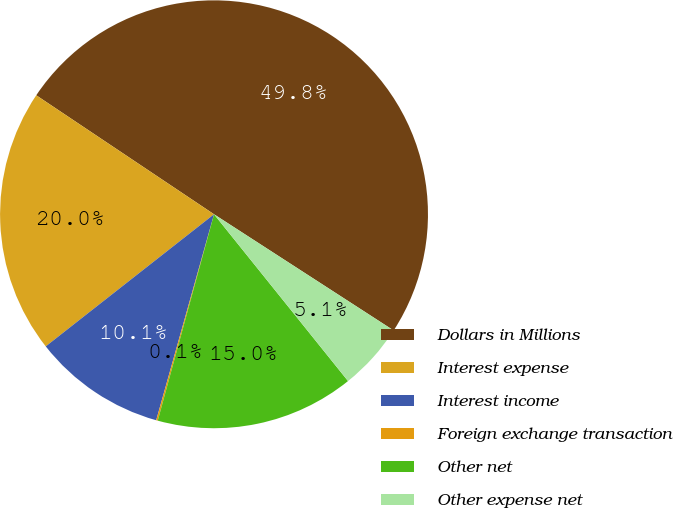Convert chart to OTSL. <chart><loc_0><loc_0><loc_500><loc_500><pie_chart><fcel>Dollars in Millions<fcel>Interest expense<fcel>Interest income<fcel>Foreign exchange transaction<fcel>Other net<fcel>Other expense net<nl><fcel>49.75%<fcel>19.98%<fcel>10.05%<fcel>0.12%<fcel>15.01%<fcel>5.09%<nl></chart> 